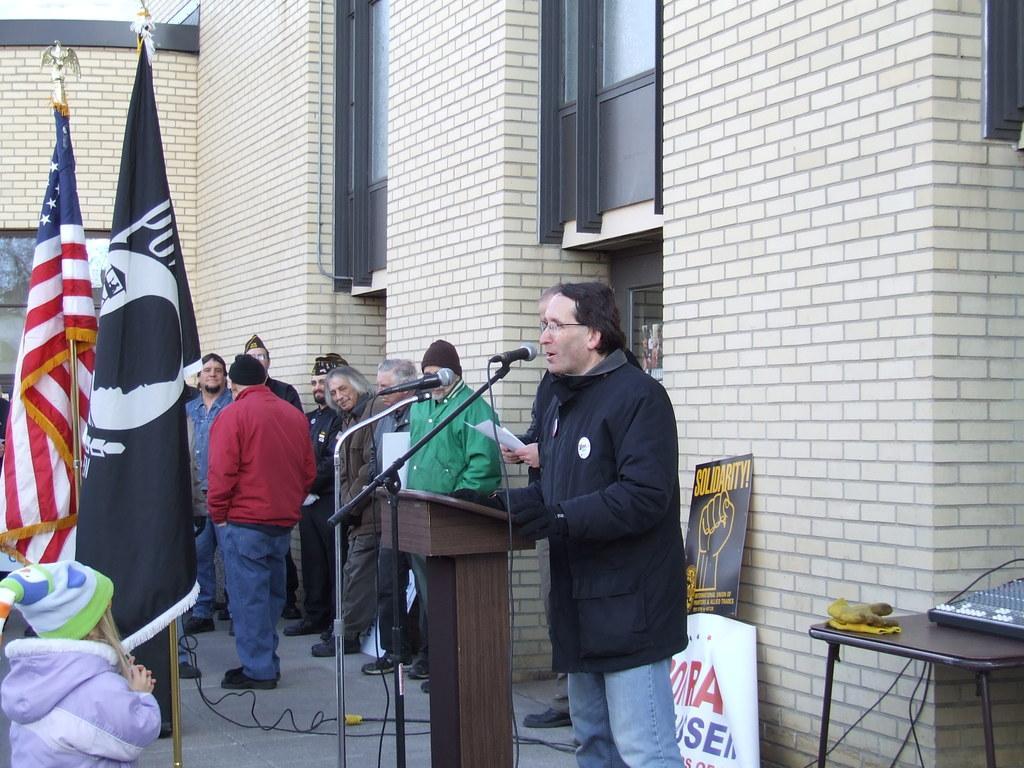Please provide a concise description of this image. As we can see in the image there are buildings, flags, mics, banner, table and few people here and there. 